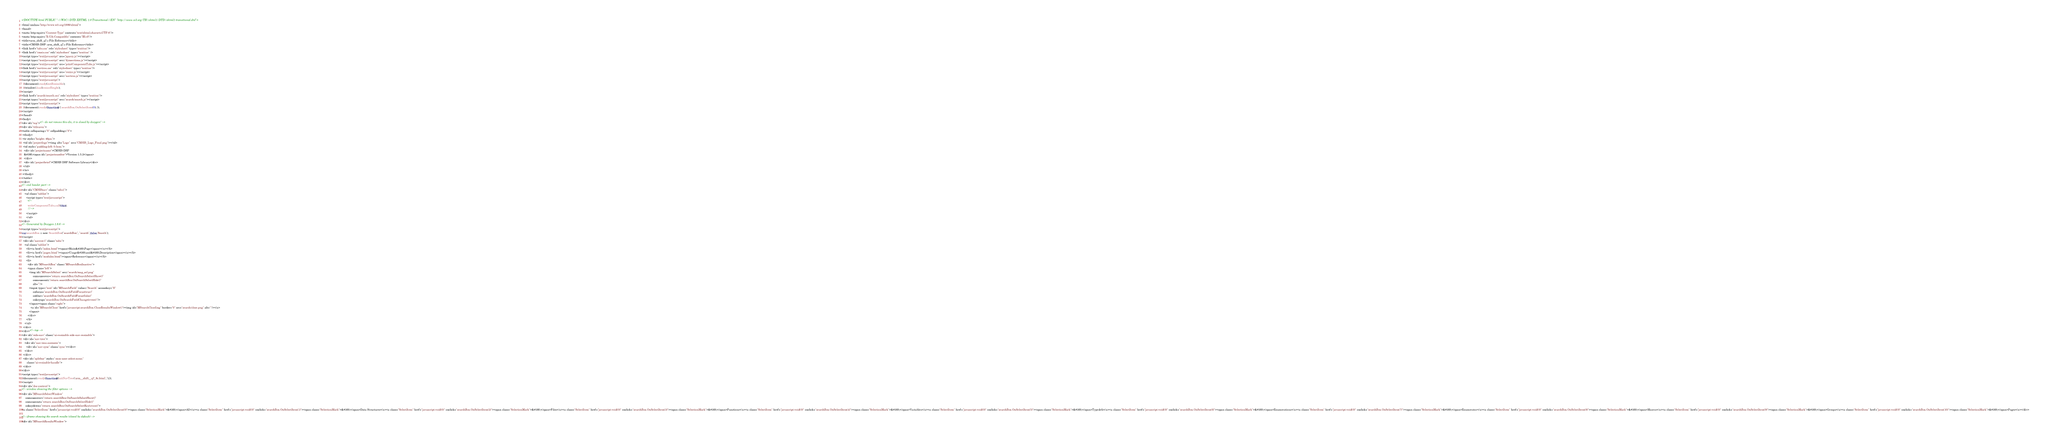Convert code to text. <code><loc_0><loc_0><loc_500><loc_500><_HTML_><!DOCTYPE html PUBLIC "-//W3C//DTD XHTML 1.0 Transitional//EN" "http://www.w3.org/TR/xhtml1/DTD/xhtml1-transitional.dtd">
<html xmlns="http://www.w3.org/1999/xhtml">
<head>
<meta http-equiv="Content-Type" content="text/xhtml;charset=UTF-8"/>
<meta http-equiv="X-UA-Compatible" content="IE=9"/>
<title>arm_shift_q7.c File Reference</title>
<title>CMSIS-DSP: arm_shift_q7.c File Reference</title>
<link href="tabs.css" rel="stylesheet" type="text/css"/>
<link href="cmsis.css" rel="stylesheet" type="text/css" />
<script type="text/javascript" src="jquery.js"></script>
<script type="text/javascript" src="dynsections.js"></script>
<script type="text/javascript" src="printComponentTabs.js"></script>
<link href="navtree.css" rel="stylesheet" type="text/css"/>
<script type="text/javascript" src="resize.js"></script>
<script type="text/javascript" src="navtree.js"></script>
<script type="text/javascript">
  $(document).ready(initResizable);
  $(window).load(resizeHeight);
</script>
<link href="search/search.css" rel="stylesheet" type="text/css"/>
<script type="text/javascript" src="search/search.js"></script>
<script type="text/javascript">
  $(document).ready(function() { searchBox.OnSelectItem(0); });
</script>
</head>
<body>
<div id="top"><!-- do not remove this div, it is closed by doxygen! -->
<div id="titlearea">
<table cellspacing="0" cellpadding="0">
 <tbody>
 <tr style="height: 46px;">
  <td id="projectlogo"><img alt="Logo" src="CMSIS_Logo_Final.png"/></td>
  <td style="padding-left: 0.5em;">
   <div id="projectname">CMSIS-DSP
   &#160;<span id="projectnumber">Version 1.5.2</span>
   </div>
   <div id="projectbrief">CMSIS DSP Software Library</div>
  </td>
 </tr>
 </tbody>
</table>
</div>
<!-- end header part -->
<div id="CMSISnav" class="tabs1">
    <ul class="tablist">
      <script type="text/javascript">
		<!--
		writeComponentTabs.call(this);
		//-->
      </script>
	  </ul>
</div>
<!-- Generated by Doxygen 1.8.6 -->
<script type="text/javascript">
var searchBox = new SearchBox("searchBox", "search",false,'Search');
</script>
  <div id="navrow1" class="tabs">
    <ul class="tablist">
      <li><a href="index.html"><span>Main&#160;Page</span></a></li>
      <li><a href="pages.html"><span>Usage&#160;and&#160;Description</span></a></li>
      <li><a href="modules.html"><span>Reference</span></a></li>
      <li>
        <div id="MSearchBox" class="MSearchBoxInactive">
        <span class="left">
          <img id="MSearchSelect" src="search/mag_sel.png"
               onmouseover="return searchBox.OnSearchSelectShow()"
               onmouseout="return searchBox.OnSearchSelectHide()"
               alt=""/>
          <input type="text" id="MSearchField" value="Search" accesskey="S"
               onfocus="searchBox.OnSearchFieldFocus(true)" 
               onblur="searchBox.OnSearchFieldFocus(false)" 
               onkeyup="searchBox.OnSearchFieldChange(event)"/>
          </span><span class="right">
            <a id="MSearchClose" href="javascript:searchBox.CloseResultsWindow()"><img id="MSearchCloseImg" border="0" src="search/close.png" alt=""/></a>
          </span>
        </div>
      </li>
    </ul>
  </div>
</div><!-- top -->
<div id="side-nav" class="ui-resizable side-nav-resizable">
  <div id="nav-tree">
    <div id="nav-tree-contents">
      <div id="nav-sync" class="sync"></div>
    </div>
  </div>
  <div id="splitbar" style="-moz-user-select:none;" 
       class="ui-resizable-handle">
  </div>
</div>
<script type="text/javascript">
$(document).ready(function(){initNavTree('arm__shift__q7_8c.html','');});
</script>
<div id="doc-content">
<!-- window showing the filter options -->
<div id="MSearchSelectWindow"
     onmouseover="return searchBox.OnSearchSelectShow()"
     onmouseout="return searchBox.OnSearchSelectHide()"
     onkeydown="return searchBox.OnSearchSelectKey(event)">
<a class="SelectItem" href="javascript:void(0)" onclick="searchBox.OnSelectItem(0)"><span class="SelectionMark">&#160;</span>All</a><a class="SelectItem" href="javascript:void(0)" onclick="searchBox.OnSelectItem(1)"><span class="SelectionMark">&#160;</span>Data Structures</a><a class="SelectItem" href="javascript:void(0)" onclick="searchBox.OnSelectItem(2)"><span class="SelectionMark">&#160;</span>Files</a><a class="SelectItem" href="javascript:void(0)" onclick="searchBox.OnSelectItem(3)"><span class="SelectionMark">&#160;</span>Functions</a><a class="SelectItem" href="javascript:void(0)" onclick="searchBox.OnSelectItem(4)"><span class="SelectionMark">&#160;</span>Variables</a><a class="SelectItem" href="javascript:void(0)" onclick="searchBox.OnSelectItem(5)"><span class="SelectionMark">&#160;</span>Typedefs</a><a class="SelectItem" href="javascript:void(0)" onclick="searchBox.OnSelectItem(6)"><span class="SelectionMark">&#160;</span>Enumerations</a><a class="SelectItem" href="javascript:void(0)" onclick="searchBox.OnSelectItem(7)"><span class="SelectionMark">&#160;</span>Enumerator</a><a class="SelectItem" href="javascript:void(0)" onclick="searchBox.OnSelectItem(8)"><span class="SelectionMark">&#160;</span>Macros</a><a class="SelectItem" href="javascript:void(0)" onclick="searchBox.OnSelectItem(9)"><span class="SelectionMark">&#160;</span>Groups</a><a class="SelectItem" href="javascript:void(0)" onclick="searchBox.OnSelectItem(10)"><span class="SelectionMark">&#160;</span>Pages</a></div>

<!-- iframe showing the search results (closed by default) -->
<div id="MSearchResultsWindow"></code> 